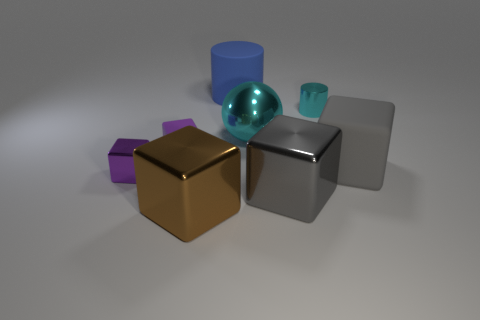There is a thing that is the same color as the large metallic ball; what is its material?
Your answer should be compact. Metal. How many big gray metallic things are left of the large blue matte thing that is behind the cylinder in front of the matte cylinder?
Your response must be concise. 0. There is a large metal ball; what number of small cyan cylinders are in front of it?
Offer a terse response. 0. There is another big rubber thing that is the same shape as the large brown object; what is its color?
Provide a short and direct response. Gray. There is a cube that is on the left side of the large matte cube and behind the purple shiny cube; what material is it?
Provide a short and direct response. Rubber. Do the rubber cube on the left side of the cyan metal cylinder and the large metallic ball have the same size?
Your response must be concise. No. What material is the cyan ball?
Offer a terse response. Metal. What color is the matte object that is behind the large sphere?
Keep it short and to the point. Blue. What number of large objects are metal spheres or brown metallic cylinders?
Your answer should be compact. 1. There is a rubber block to the right of the big gray metal object; does it have the same color as the big shiny object behind the small purple matte object?
Offer a very short reply. No. 